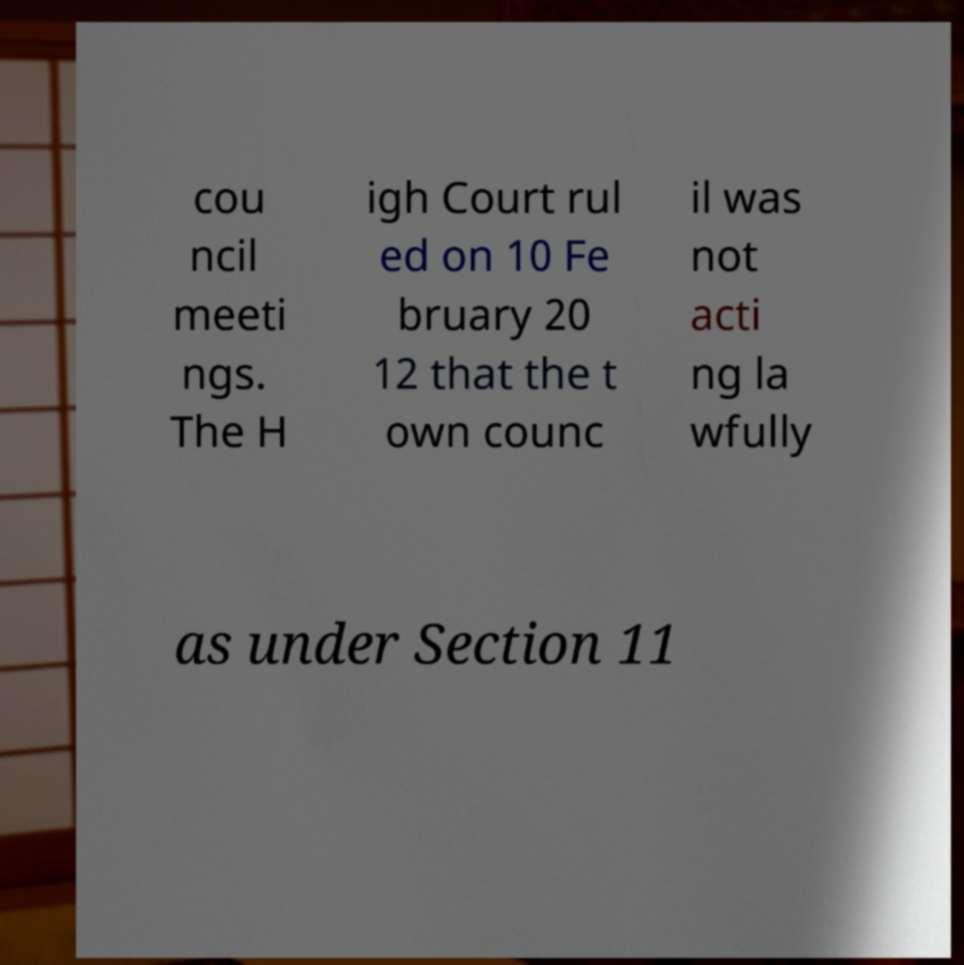For documentation purposes, I need the text within this image transcribed. Could you provide that? cou ncil meeti ngs. The H igh Court rul ed on 10 Fe bruary 20 12 that the t own counc il was not acti ng la wfully as under Section 11 